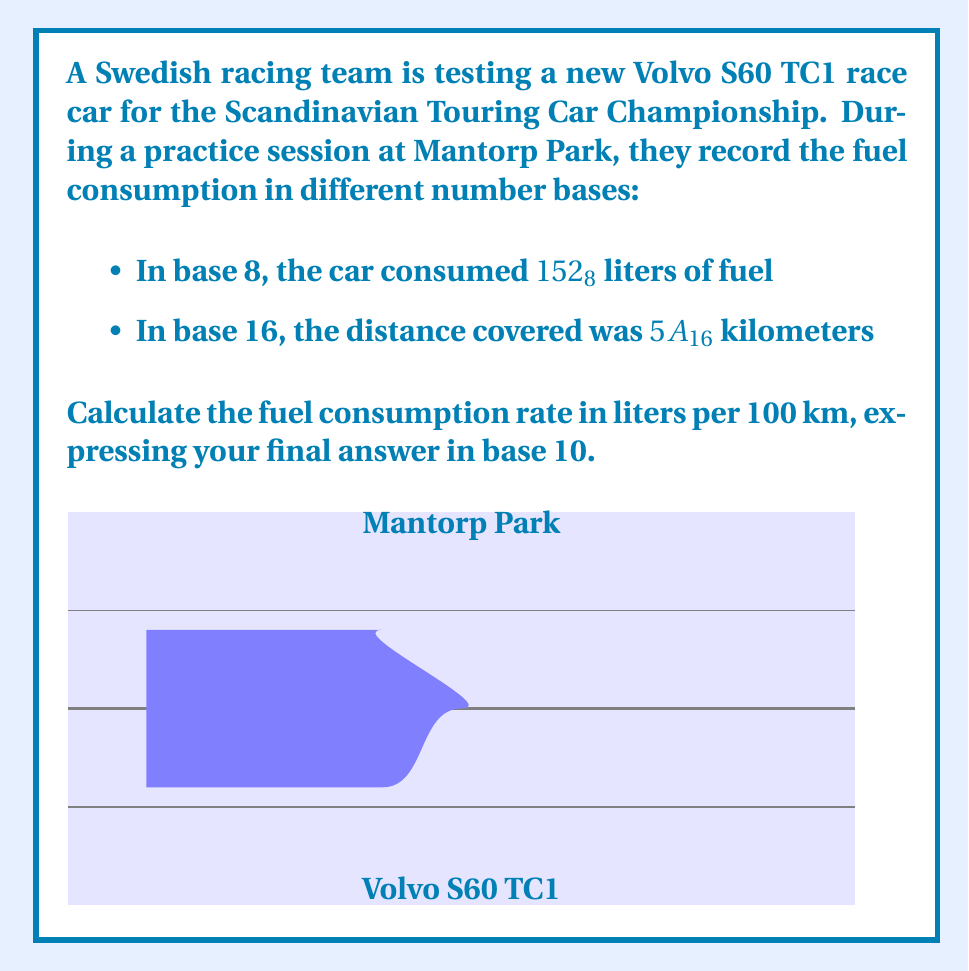Help me with this question. Let's approach this problem step-by-step:

1) First, we need to convert the fuel consumption from base 8 to base 10:
   $$152_8 = 1 \times 8^2 + 5 \times 8^1 + 2 \times 8^0 = 64 + 40 + 2 = 106_{10}$$ liters

2) Next, we convert the distance from base 16 to base 10:
   $$5A_{16} = 5 \times 16^1 + 10 \times 16^0 = 80 + 10 = 90_{10}$$ kilometers

3) Now we have the fuel consumption (106 liters) and distance (90 km) in base 10.

4) To calculate the fuel consumption rate in liters per 100 km, we use the formula:
   $$\text{Rate} = \frac{\text{Fuel consumed}}{\text{Distance}} \times 100$$

5) Plugging in our values:
   $$\text{Rate} = \frac{106}{90} \times 100 = 117.7777...$$ liters per 100 km

6) Rounding to two decimal places, we get 117.78 liters per 100 km.
Answer: $117.78_{10}$ L/100km 